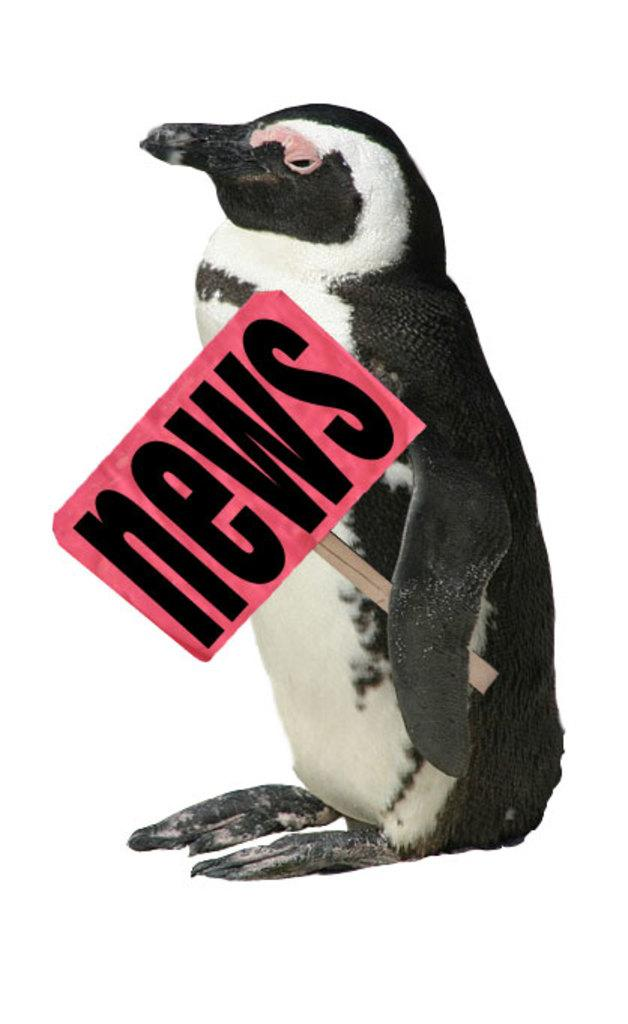What is the main subject of the image? There is a penguin in the center of the image. What is the penguin holding in the image? The penguin is holding a board. What can be seen on the board? There is text on the board. What is the color of the board's background? The background of the board is white. What type of toothpaste is the penguin using in the image? There is no toothpaste present in the image; it features a penguin holding a board with text on it. What kind of beef dish is the penguin preparing in the image? There is no beef dish or cooking activity depicted in the image; it only shows a penguin holding a board with text on it. 